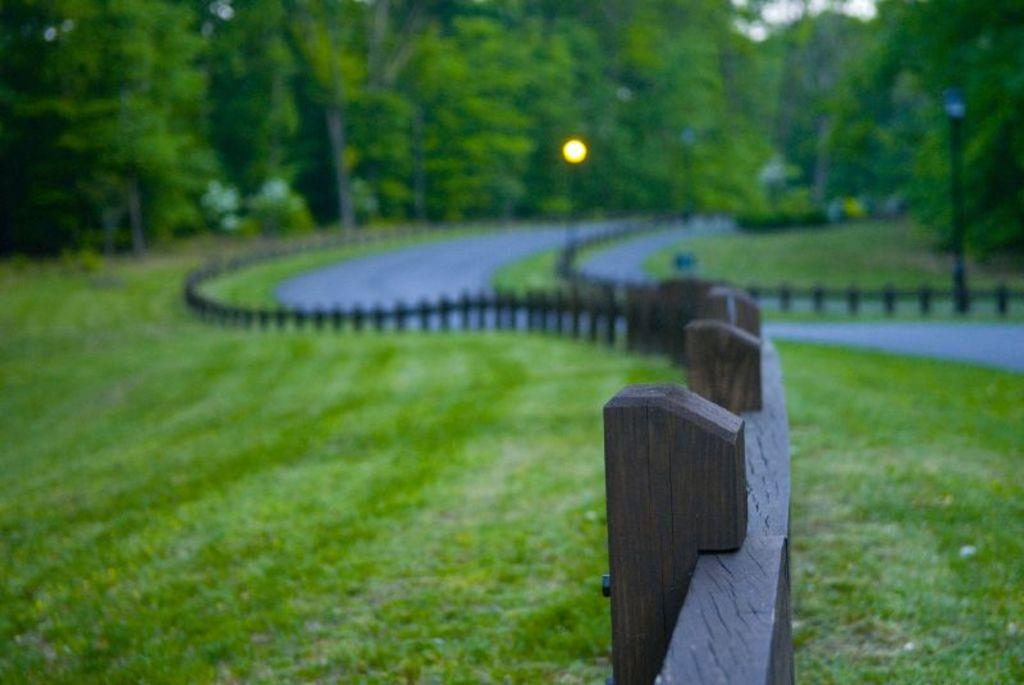What type of vegetation can be seen in the image? There are trees in the image. What can be seen illuminating the area in the image? There are lights in the image. What structures are supporting the lights in the image? There are poles in the image. What type of pathway is visible in the image? There is a road in the image. What safety feature can be seen in the image? There are railings in the image. What type of ground cover is present in the image? There is grass in the image. What word is written on the shelf in the image? There is no shelf present in the image, so no word can be found on it. What year does the image depict? The image does not depict a specific year, as it is a static representation of the scene. 